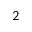Convert formula to latex. <formula><loc_0><loc_0><loc_500><loc_500>_ { 2 }</formula> 